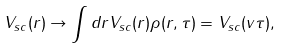Convert formula to latex. <formula><loc_0><loc_0><loc_500><loc_500>V _ { s c } ( r ) \rightarrow \int d { r } V _ { s c } ( r ) \rho ( { r } , \tau ) = V _ { s c } ( v \tau ) ,</formula> 